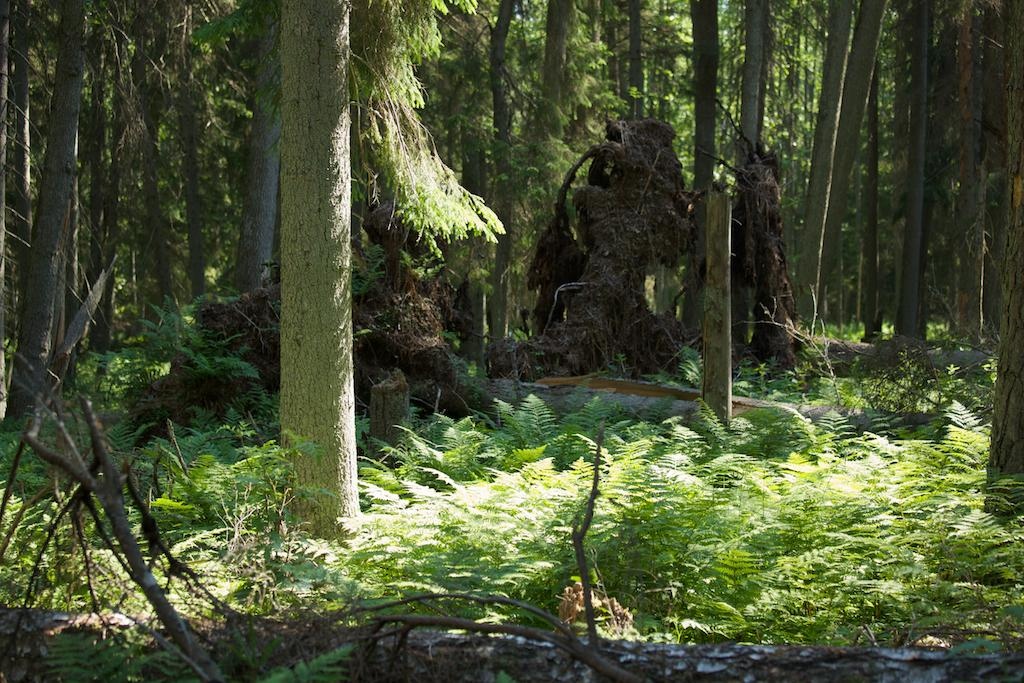What type of living organisms can be seen in the image? Plants and trees are visible in the image. What color are the plants in the image? The plants are green in color. What color are some of the trees in the image? Some trees in the image are brown in color. What is the condition of these brown trees in the image? These brown trees appear to be fallen. How many toothbrushes can be seen in the image? There are no toothbrushes present in the image. What type of trucks can be seen in the image? There are no trucks present in the image. 